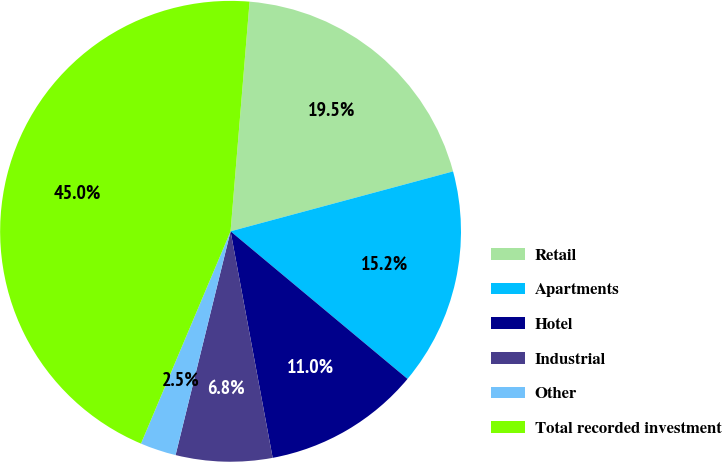<chart> <loc_0><loc_0><loc_500><loc_500><pie_chart><fcel>Retail<fcel>Apartments<fcel>Hotel<fcel>Industrial<fcel>Other<fcel>Total recorded investment<nl><fcel>19.5%<fcel>15.25%<fcel>11.01%<fcel>6.76%<fcel>2.52%<fcel>44.96%<nl></chart> 